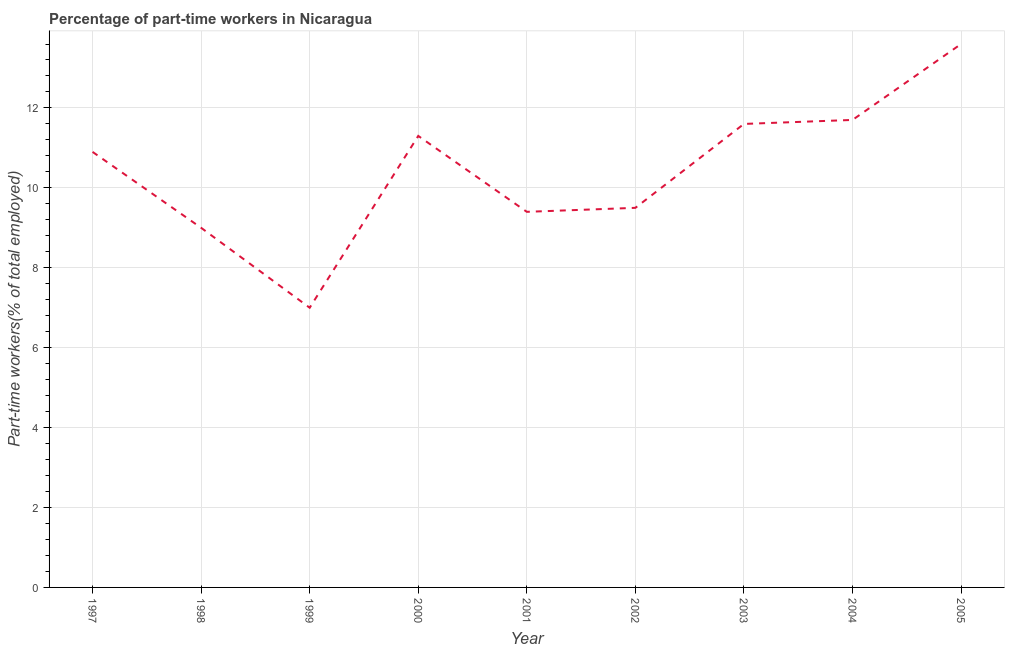Across all years, what is the maximum percentage of part-time workers?
Offer a very short reply. 13.6. Across all years, what is the minimum percentage of part-time workers?
Keep it short and to the point. 7. In which year was the percentage of part-time workers maximum?
Ensure brevity in your answer.  2005. In which year was the percentage of part-time workers minimum?
Provide a short and direct response. 1999. What is the sum of the percentage of part-time workers?
Provide a succinct answer. 94. What is the difference between the percentage of part-time workers in 1998 and 2003?
Offer a terse response. -2.6. What is the average percentage of part-time workers per year?
Ensure brevity in your answer.  10.44. What is the median percentage of part-time workers?
Offer a terse response. 10.9. In how many years, is the percentage of part-time workers greater than 12.4 %?
Your answer should be very brief. 1. What is the ratio of the percentage of part-time workers in 1999 to that in 2005?
Offer a terse response. 0.51. What is the difference between the highest and the second highest percentage of part-time workers?
Your answer should be compact. 1.9. What is the difference between the highest and the lowest percentage of part-time workers?
Your answer should be very brief. 6.6. Does the percentage of part-time workers monotonically increase over the years?
Make the answer very short. No. How many years are there in the graph?
Your answer should be very brief. 9. What is the difference between two consecutive major ticks on the Y-axis?
Offer a terse response. 2. Are the values on the major ticks of Y-axis written in scientific E-notation?
Make the answer very short. No. Does the graph contain any zero values?
Keep it short and to the point. No. Does the graph contain grids?
Provide a succinct answer. Yes. What is the title of the graph?
Offer a very short reply. Percentage of part-time workers in Nicaragua. What is the label or title of the Y-axis?
Make the answer very short. Part-time workers(% of total employed). What is the Part-time workers(% of total employed) in 1997?
Offer a terse response. 10.9. What is the Part-time workers(% of total employed) of 2000?
Provide a succinct answer. 11.3. What is the Part-time workers(% of total employed) of 2001?
Your answer should be compact. 9.4. What is the Part-time workers(% of total employed) in 2002?
Your answer should be compact. 9.5. What is the Part-time workers(% of total employed) of 2003?
Your response must be concise. 11.6. What is the Part-time workers(% of total employed) in 2004?
Offer a terse response. 11.7. What is the Part-time workers(% of total employed) of 2005?
Make the answer very short. 13.6. What is the difference between the Part-time workers(% of total employed) in 1997 and 1998?
Your answer should be very brief. 1.9. What is the difference between the Part-time workers(% of total employed) in 1997 and 2000?
Your answer should be very brief. -0.4. What is the difference between the Part-time workers(% of total employed) in 1997 and 2001?
Your answer should be compact. 1.5. What is the difference between the Part-time workers(% of total employed) in 1997 and 2002?
Keep it short and to the point. 1.4. What is the difference between the Part-time workers(% of total employed) in 1997 and 2003?
Your response must be concise. -0.7. What is the difference between the Part-time workers(% of total employed) in 1997 and 2004?
Offer a very short reply. -0.8. What is the difference between the Part-time workers(% of total employed) in 1998 and 1999?
Your answer should be very brief. 2. What is the difference between the Part-time workers(% of total employed) in 1998 and 2000?
Your answer should be compact. -2.3. What is the difference between the Part-time workers(% of total employed) in 1998 and 2003?
Offer a very short reply. -2.6. What is the difference between the Part-time workers(% of total employed) in 1999 and 2002?
Provide a succinct answer. -2.5. What is the difference between the Part-time workers(% of total employed) in 2000 and 2001?
Offer a very short reply. 1.9. What is the difference between the Part-time workers(% of total employed) in 2000 and 2003?
Your answer should be compact. -0.3. What is the difference between the Part-time workers(% of total employed) in 2000 and 2004?
Offer a terse response. -0.4. What is the difference between the Part-time workers(% of total employed) in 2000 and 2005?
Give a very brief answer. -2.3. What is the difference between the Part-time workers(% of total employed) in 2001 and 2003?
Offer a very short reply. -2.2. What is the difference between the Part-time workers(% of total employed) in 2001 and 2004?
Offer a terse response. -2.3. What is the difference between the Part-time workers(% of total employed) in 2002 and 2003?
Your answer should be very brief. -2.1. What is the difference between the Part-time workers(% of total employed) in 2003 and 2004?
Your answer should be very brief. -0.1. What is the difference between the Part-time workers(% of total employed) in 2003 and 2005?
Make the answer very short. -2. What is the difference between the Part-time workers(% of total employed) in 2004 and 2005?
Your response must be concise. -1.9. What is the ratio of the Part-time workers(% of total employed) in 1997 to that in 1998?
Your answer should be compact. 1.21. What is the ratio of the Part-time workers(% of total employed) in 1997 to that in 1999?
Keep it short and to the point. 1.56. What is the ratio of the Part-time workers(% of total employed) in 1997 to that in 2000?
Your answer should be very brief. 0.96. What is the ratio of the Part-time workers(% of total employed) in 1997 to that in 2001?
Provide a succinct answer. 1.16. What is the ratio of the Part-time workers(% of total employed) in 1997 to that in 2002?
Provide a succinct answer. 1.15. What is the ratio of the Part-time workers(% of total employed) in 1997 to that in 2003?
Your answer should be very brief. 0.94. What is the ratio of the Part-time workers(% of total employed) in 1997 to that in 2004?
Keep it short and to the point. 0.93. What is the ratio of the Part-time workers(% of total employed) in 1997 to that in 2005?
Give a very brief answer. 0.8. What is the ratio of the Part-time workers(% of total employed) in 1998 to that in 1999?
Provide a succinct answer. 1.29. What is the ratio of the Part-time workers(% of total employed) in 1998 to that in 2000?
Offer a terse response. 0.8. What is the ratio of the Part-time workers(% of total employed) in 1998 to that in 2002?
Your answer should be very brief. 0.95. What is the ratio of the Part-time workers(% of total employed) in 1998 to that in 2003?
Your response must be concise. 0.78. What is the ratio of the Part-time workers(% of total employed) in 1998 to that in 2004?
Your answer should be very brief. 0.77. What is the ratio of the Part-time workers(% of total employed) in 1998 to that in 2005?
Ensure brevity in your answer.  0.66. What is the ratio of the Part-time workers(% of total employed) in 1999 to that in 2000?
Offer a terse response. 0.62. What is the ratio of the Part-time workers(% of total employed) in 1999 to that in 2001?
Give a very brief answer. 0.74. What is the ratio of the Part-time workers(% of total employed) in 1999 to that in 2002?
Ensure brevity in your answer.  0.74. What is the ratio of the Part-time workers(% of total employed) in 1999 to that in 2003?
Offer a very short reply. 0.6. What is the ratio of the Part-time workers(% of total employed) in 1999 to that in 2004?
Your answer should be very brief. 0.6. What is the ratio of the Part-time workers(% of total employed) in 1999 to that in 2005?
Provide a succinct answer. 0.52. What is the ratio of the Part-time workers(% of total employed) in 2000 to that in 2001?
Your response must be concise. 1.2. What is the ratio of the Part-time workers(% of total employed) in 2000 to that in 2002?
Your response must be concise. 1.19. What is the ratio of the Part-time workers(% of total employed) in 2000 to that in 2004?
Offer a very short reply. 0.97. What is the ratio of the Part-time workers(% of total employed) in 2000 to that in 2005?
Give a very brief answer. 0.83. What is the ratio of the Part-time workers(% of total employed) in 2001 to that in 2002?
Offer a very short reply. 0.99. What is the ratio of the Part-time workers(% of total employed) in 2001 to that in 2003?
Your answer should be compact. 0.81. What is the ratio of the Part-time workers(% of total employed) in 2001 to that in 2004?
Make the answer very short. 0.8. What is the ratio of the Part-time workers(% of total employed) in 2001 to that in 2005?
Give a very brief answer. 0.69. What is the ratio of the Part-time workers(% of total employed) in 2002 to that in 2003?
Keep it short and to the point. 0.82. What is the ratio of the Part-time workers(% of total employed) in 2002 to that in 2004?
Your response must be concise. 0.81. What is the ratio of the Part-time workers(% of total employed) in 2002 to that in 2005?
Provide a succinct answer. 0.7. What is the ratio of the Part-time workers(% of total employed) in 2003 to that in 2005?
Your response must be concise. 0.85. What is the ratio of the Part-time workers(% of total employed) in 2004 to that in 2005?
Your response must be concise. 0.86. 